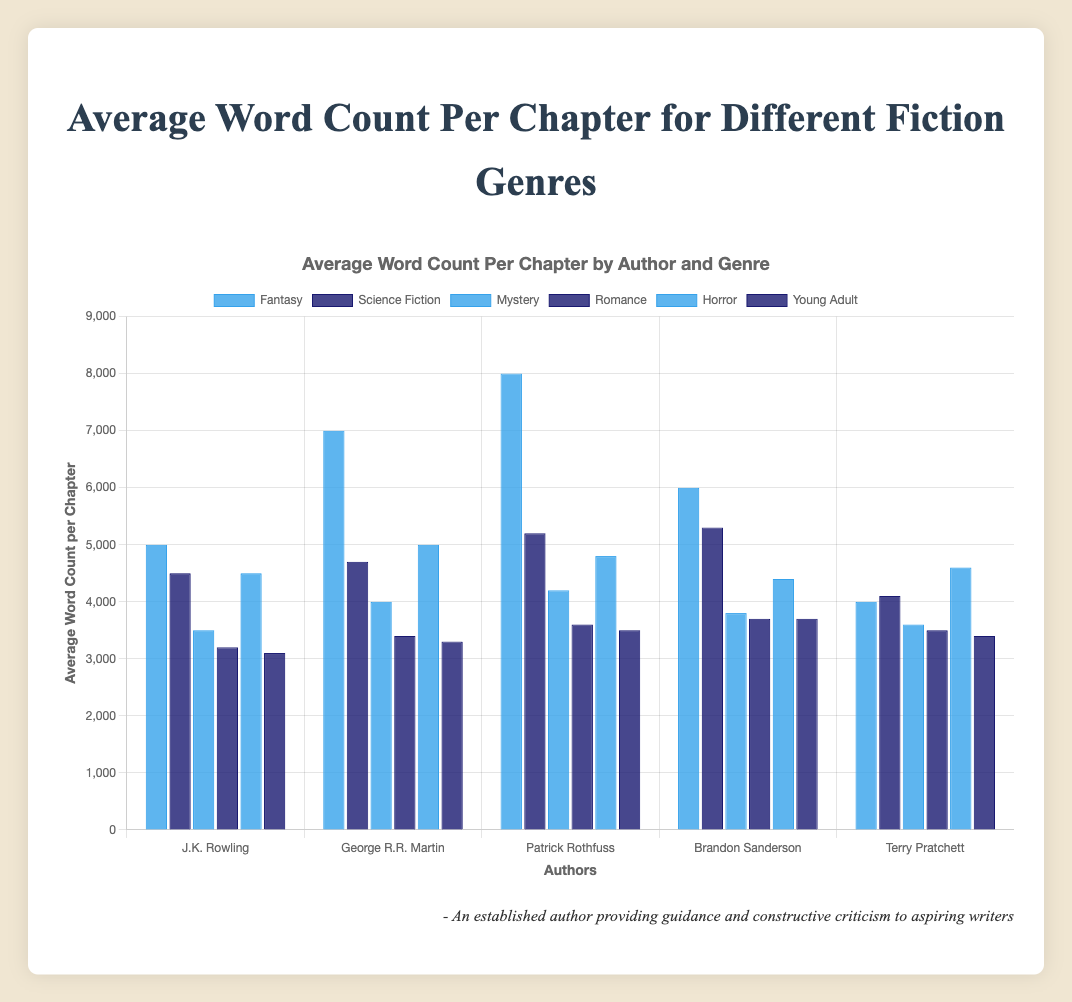Which Fantasy author has the highest average word count per chapter? By looking at the bars in the Fantasy genre, Patrick Rothfuss has the highest bar, indicating the highest average word count per chapter.
Answer: Patrick Rothfuss Compare the average word count per chapter between Fantasy and Science Fiction genres. Which genre has the higher maximum average word count per chapter? The tallest bar in Fantasy is Patrick Rothfuss with 8000 words, while the tallest bar in Science Fiction is Ursula K. Le Guin with 5300 words. Thus, Fantasy has the higher maximum average word count per chapter.
Answer: Fantasy Who has the lowest average word count per chapter among Mystery authors? Among the Mystery authors, Agatha Christie's bar is the shortest, indicating she has the lowest average word count per chapter.
Answer: Agatha Christie What's the average of the highest average word count chapters for Fantasy and Horror genres? The highest average word count per chapter in Fantasy is 8000 (Patrick Rothfuss) and in Horror is 5000 (H.P. Lovecraft). The average of these two values is (8000 + 5000)/2 = 6500.
Answer: 6500 Which Young Adult author has a higher average word count per chapter compared to Veronica Roth? In Young Adult genre, Cassandra Clare's bar is higher than Veronica Roth's, implying Cassanda Clare has a higher average word count per chapter compared to Veronica Roth.
Answer: Cassandra Clare Who has the highest bar in Romance genre, indicating the highest average word count per chapter? In the Romance genre, Susan Elizabeth Phillips has the highest bar, indicating the highest average word count per chapter.
Answer: Susan Elizabeth Phillips Is there an author with an average word count per chapter exactly 4000? If so, who? By examining all the bars in the chart, the author with an average word count exactly 4000 per chapter is Terry Pratchett in Fantasy and Arthur Conan Doyle in Mystery.
Answer: Terry Pratchett, Arthur Conan Doyle Compare the difference in the average word count per chapter between Stephen King and William Gibson. Stephen King's average word count per chapter is 4500 and William Gibson's is 4100. The difference is 4500 - 4100 = 400.
Answer: 400 In which genre's average word count per chapter distribution does George R.R. Martin belong, and what is his average word count? George R.R. Martin's bar is in the Fantasy genre, and his average word count per chapter is 7000.
Answer: Fantasy, 7000 